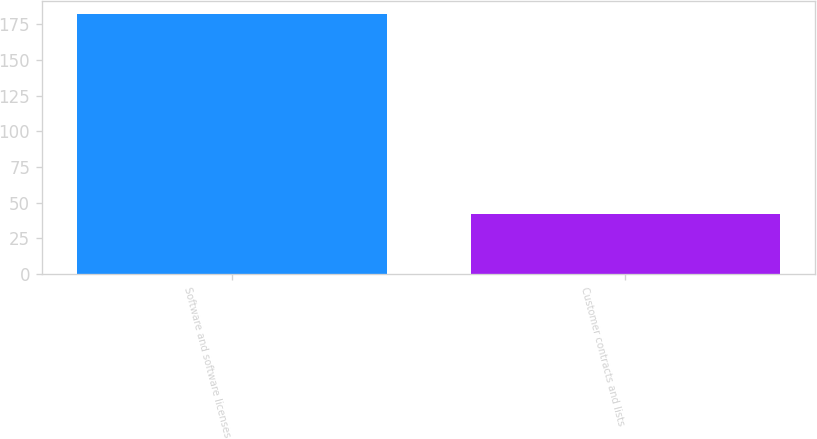Convert chart to OTSL. <chart><loc_0><loc_0><loc_500><loc_500><bar_chart><fcel>Software and software licenses<fcel>Customer contracts and lists<nl><fcel>182.2<fcel>42.1<nl></chart> 